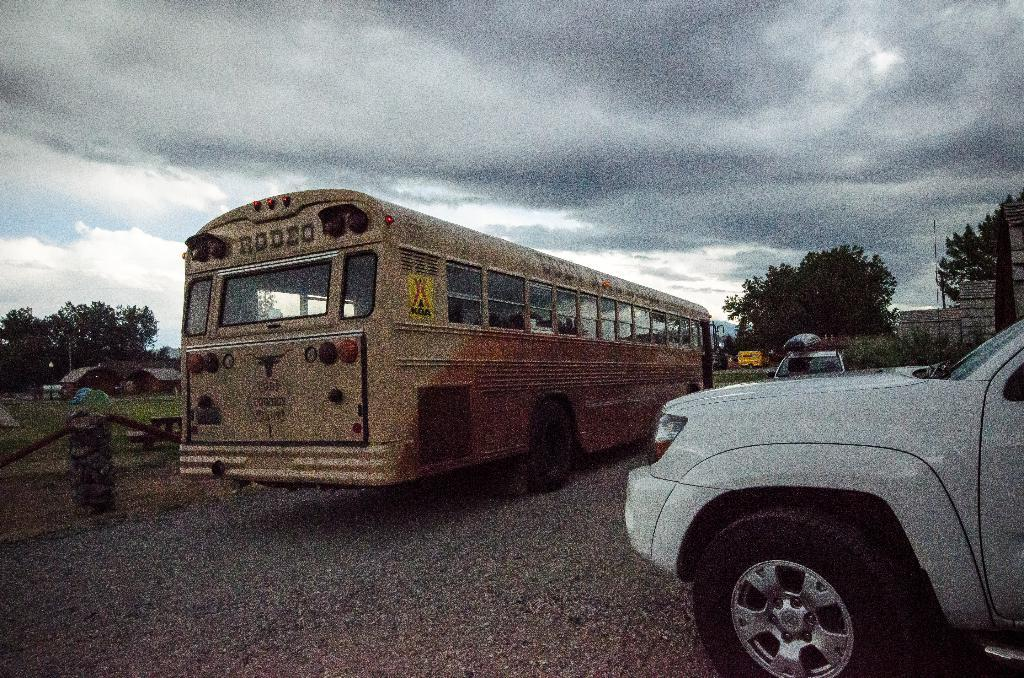<image>
Describe the image concisely. A white vehicle sitting to the right of a yellow school bus that has Rodeo on the back of it. 